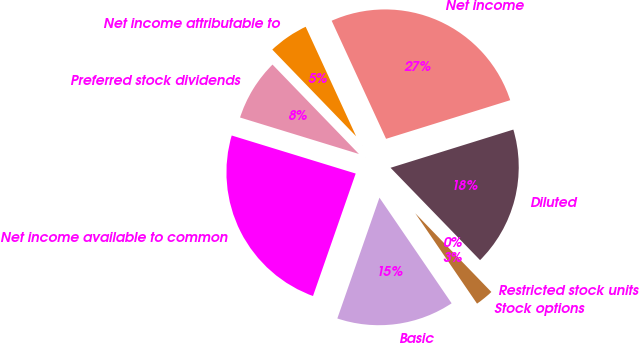Convert chart to OTSL. <chart><loc_0><loc_0><loc_500><loc_500><pie_chart><fcel>Net income<fcel>Net income attributable to<fcel>Preferred stock dividends<fcel>Net income available to common<fcel>Basic<fcel>Stock options<fcel>Restricted stock units<fcel>Diluted<nl><fcel>27.07%<fcel>5.36%<fcel>8.03%<fcel>24.4%<fcel>14.88%<fcel>2.69%<fcel>0.02%<fcel>17.55%<nl></chart> 